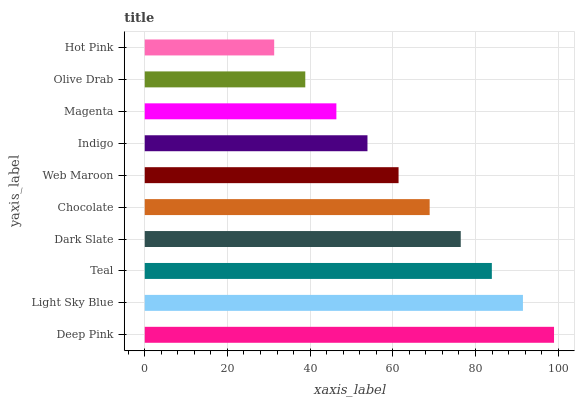Is Hot Pink the minimum?
Answer yes or no. Yes. Is Deep Pink the maximum?
Answer yes or no. Yes. Is Light Sky Blue the minimum?
Answer yes or no. No. Is Light Sky Blue the maximum?
Answer yes or no. No. Is Deep Pink greater than Light Sky Blue?
Answer yes or no. Yes. Is Light Sky Blue less than Deep Pink?
Answer yes or no. Yes. Is Light Sky Blue greater than Deep Pink?
Answer yes or no. No. Is Deep Pink less than Light Sky Blue?
Answer yes or no. No. Is Chocolate the high median?
Answer yes or no. Yes. Is Web Maroon the low median?
Answer yes or no. Yes. Is Web Maroon the high median?
Answer yes or no. No. Is Teal the low median?
Answer yes or no. No. 